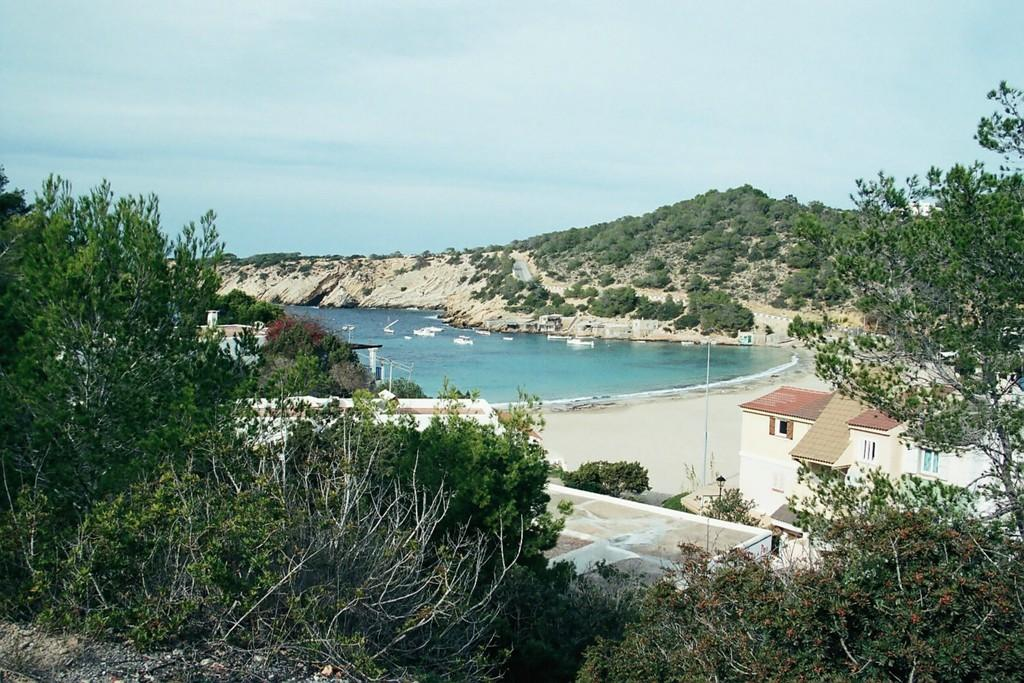What type of natural elements can be seen in the image? There are trees and plants visible in the image. What is the water feature in the image? There is water visible in the image. What type of structures are present in the image? There are houses and poles visible in the image. What other objects can be seen on the ground in the image? There are other objects on the ground in the image. What can be seen in the background of the image? Boats and the sky are visible in the background of the image. How long does it take for the airport to smash in the image? There is no airport present in the image, so it is not possible to determine how long it would take for it to smash. 